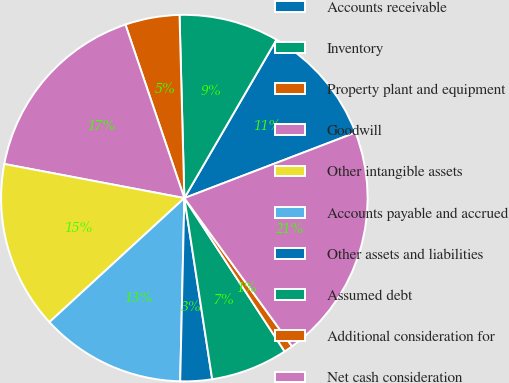<chart> <loc_0><loc_0><loc_500><loc_500><pie_chart><fcel>Accounts receivable<fcel>Inventory<fcel>Property plant and equipment<fcel>Goodwill<fcel>Other intangible assets<fcel>Accounts payable and accrued<fcel>Other assets and liabilities<fcel>Assumed debt<fcel>Additional consideration for<fcel>Net cash consideration<nl><fcel>10.8%<fcel>8.8%<fcel>4.79%<fcel>16.81%<fcel>14.81%<fcel>12.81%<fcel>2.79%<fcel>6.79%<fcel>0.78%<fcel>20.82%<nl></chart> 